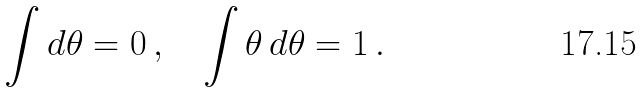Convert formula to latex. <formula><loc_0><loc_0><loc_500><loc_500>\int d \theta = 0 \, , \quad \int \theta \, d \theta = 1 \, .</formula> 